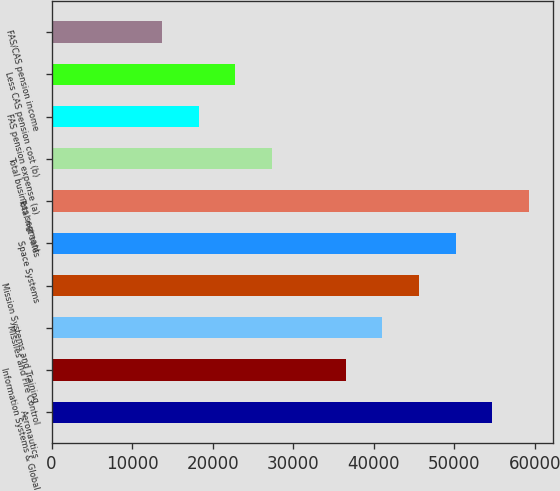Convert chart to OTSL. <chart><loc_0><loc_0><loc_500><loc_500><bar_chart><fcel>Aeronautics<fcel>Information Systems & Global<fcel>Missiles and Fire Control<fcel>Mission Systems and Training<fcel>Space Systems<fcel>Total net sales<fcel>Total business segment<fcel>FAS pension expense (a)<fcel>Less CAS pension cost (b)<fcel>FAS/CAS pension income<nl><fcel>54719.2<fcel>36480.8<fcel>41040.4<fcel>45600<fcel>50159.6<fcel>59278.8<fcel>27361.6<fcel>18242.4<fcel>22802<fcel>13682.8<nl></chart> 